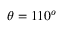Convert formula to latex. <formula><loc_0><loc_0><loc_500><loc_500>\theta = 1 1 0 ^ { o }</formula> 